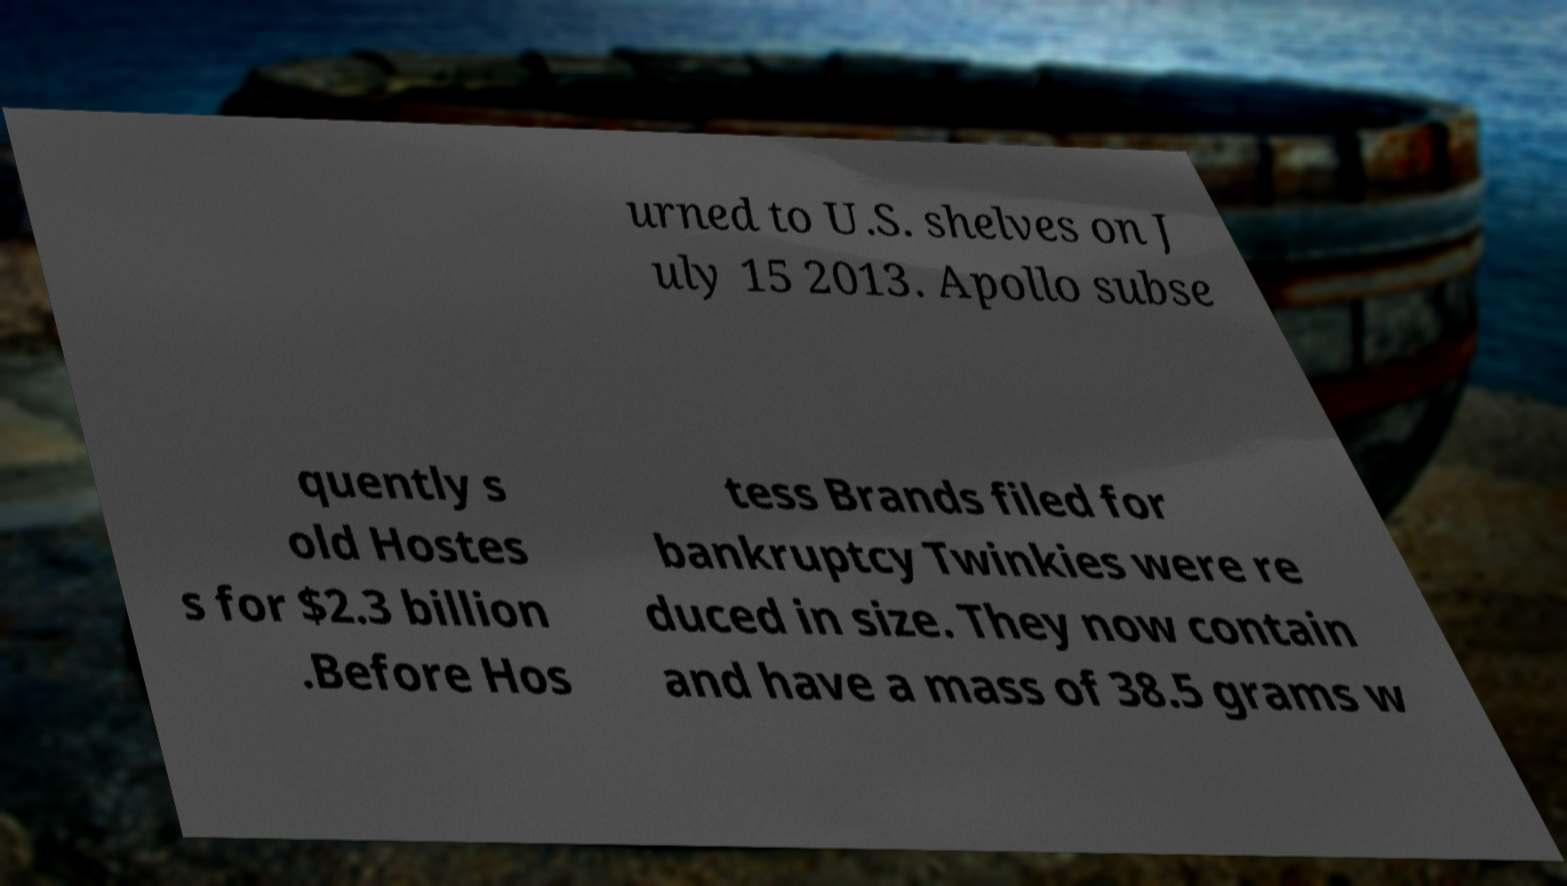There's text embedded in this image that I need extracted. Can you transcribe it verbatim? urned to U.S. shelves on J uly 15 2013. Apollo subse quently s old Hostes s for $2.3 billion .Before Hos tess Brands filed for bankruptcy Twinkies were re duced in size. They now contain and have a mass of 38.5 grams w 